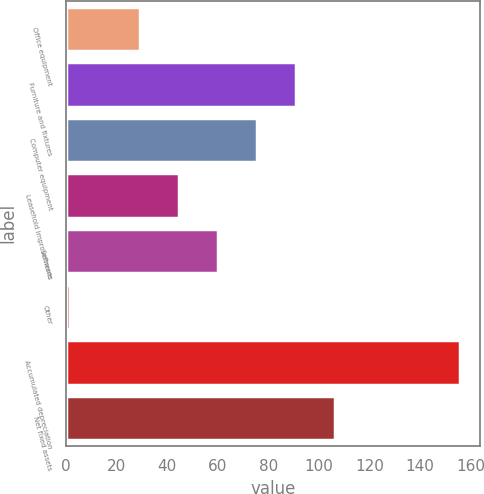Convert chart to OTSL. <chart><loc_0><loc_0><loc_500><loc_500><bar_chart><fcel>Office equipment<fcel>Furniture and fixtures<fcel>Computer equipment<fcel>Leasehold improvements<fcel>Software<fcel>Other<fcel>Accumulated depreciation<fcel>Net fixed assets<nl><fcel>29.3<fcel>90.94<fcel>75.53<fcel>44.71<fcel>60.12<fcel>1.8<fcel>155.9<fcel>106.35<nl></chart> 